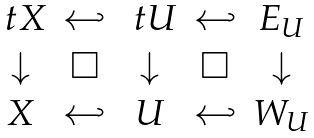Convert formula to latex. <formula><loc_0><loc_0><loc_500><loc_500>\begin{matrix} \ t X & \hookleftarrow & \ t U & \hookleftarrow & E _ { U } \\ \downarrow & \square & \downarrow & \square & \downarrow \\ X & \hookleftarrow & U & \hookleftarrow & W _ { U } \\ \end{matrix}</formula> 